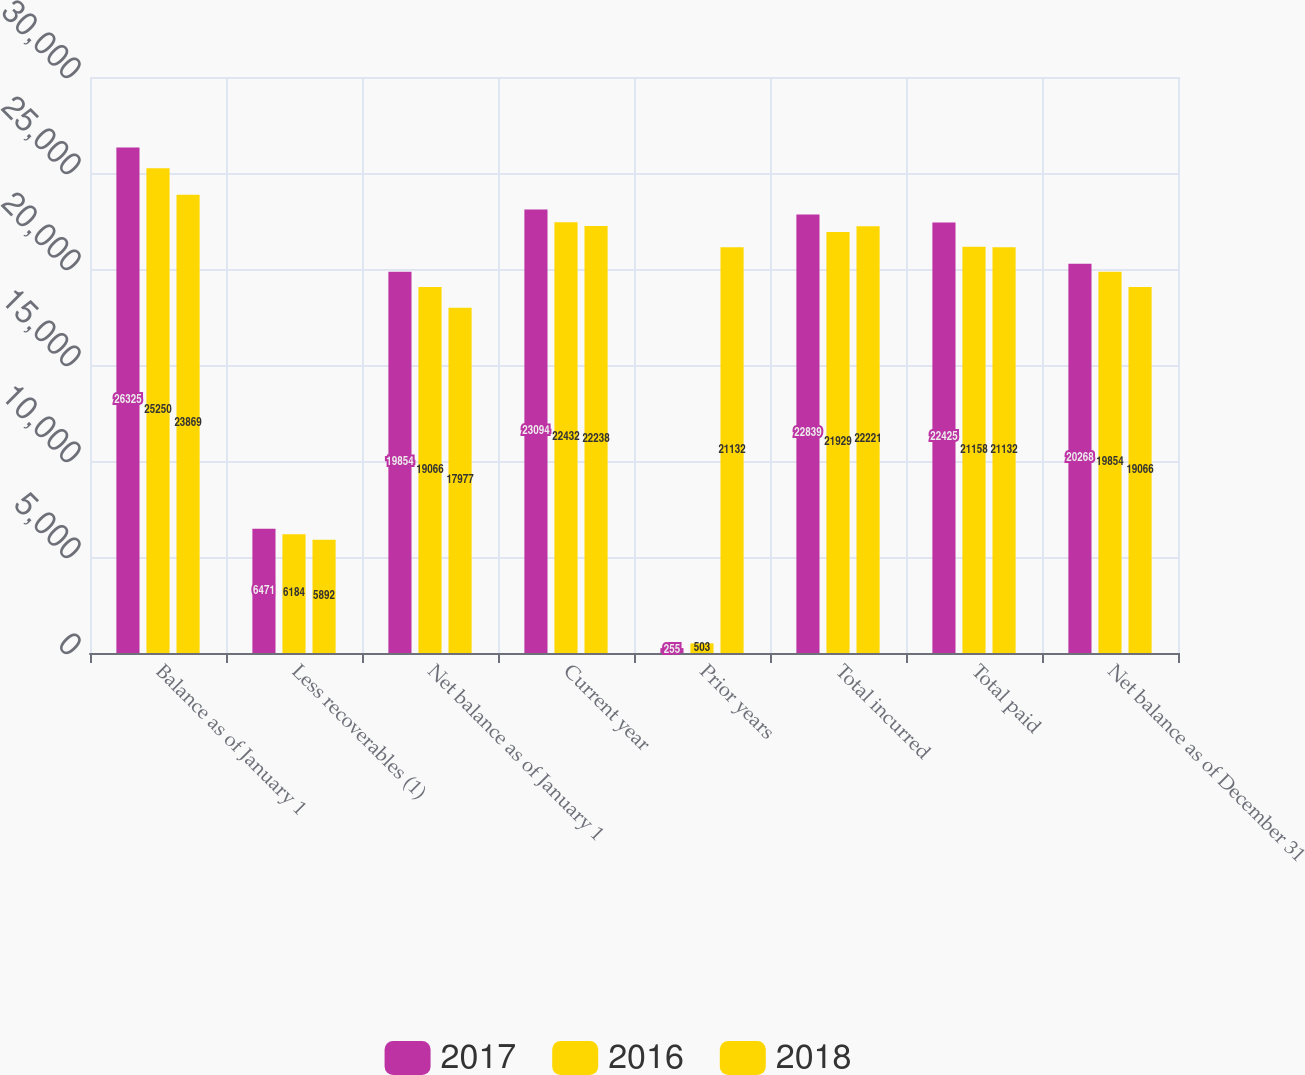<chart> <loc_0><loc_0><loc_500><loc_500><stacked_bar_chart><ecel><fcel>Balance as of January 1<fcel>Less recoverables (1)<fcel>Net balance as of January 1<fcel>Current year<fcel>Prior years<fcel>Total incurred<fcel>Total paid<fcel>Net balance as of December 31<nl><fcel>2017<fcel>26325<fcel>6471<fcel>19854<fcel>23094<fcel>255<fcel>22839<fcel>22425<fcel>20268<nl><fcel>2016<fcel>25250<fcel>6184<fcel>19066<fcel>22432<fcel>503<fcel>21929<fcel>21158<fcel>19854<nl><fcel>2018<fcel>23869<fcel>5892<fcel>17977<fcel>22238<fcel>21132<fcel>22221<fcel>21132<fcel>19066<nl></chart> 